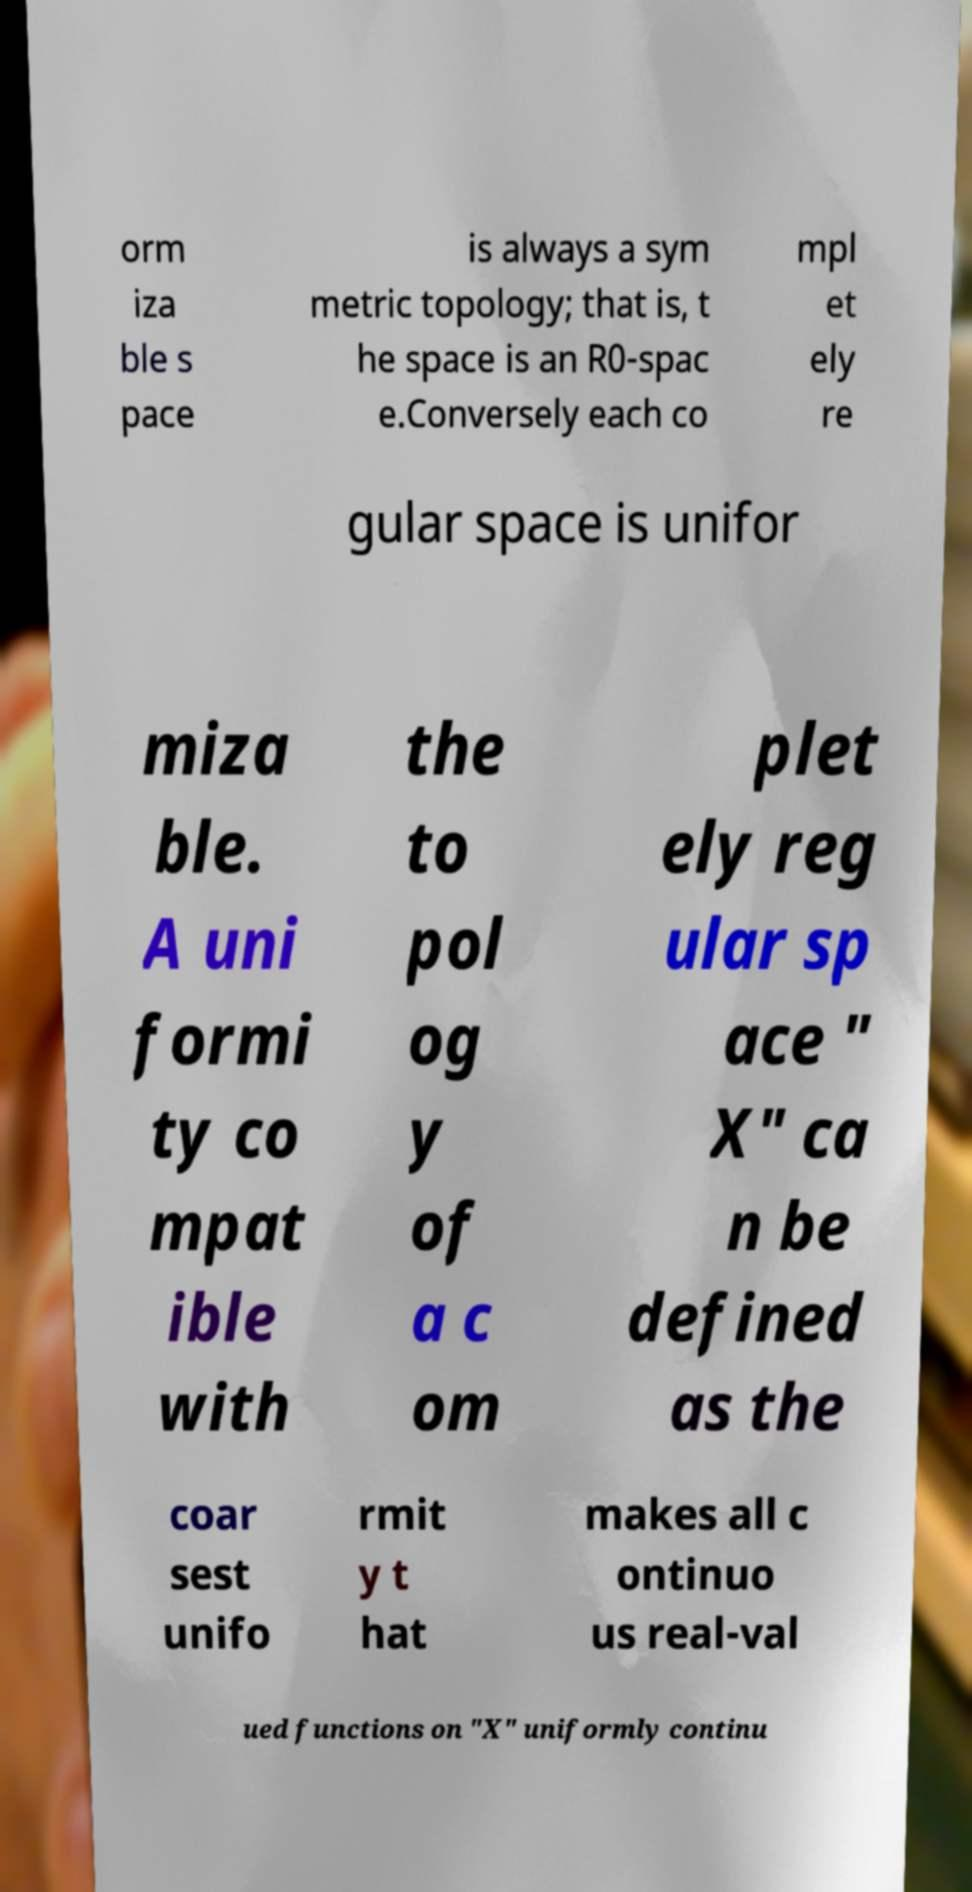Could you extract and type out the text from this image? orm iza ble s pace is always a sym metric topology; that is, t he space is an R0-spac e.Conversely each co mpl et ely re gular space is unifor miza ble. A uni formi ty co mpat ible with the to pol og y of a c om plet ely reg ular sp ace " X" ca n be defined as the coar sest unifo rmit y t hat makes all c ontinuo us real-val ued functions on "X" uniformly continu 